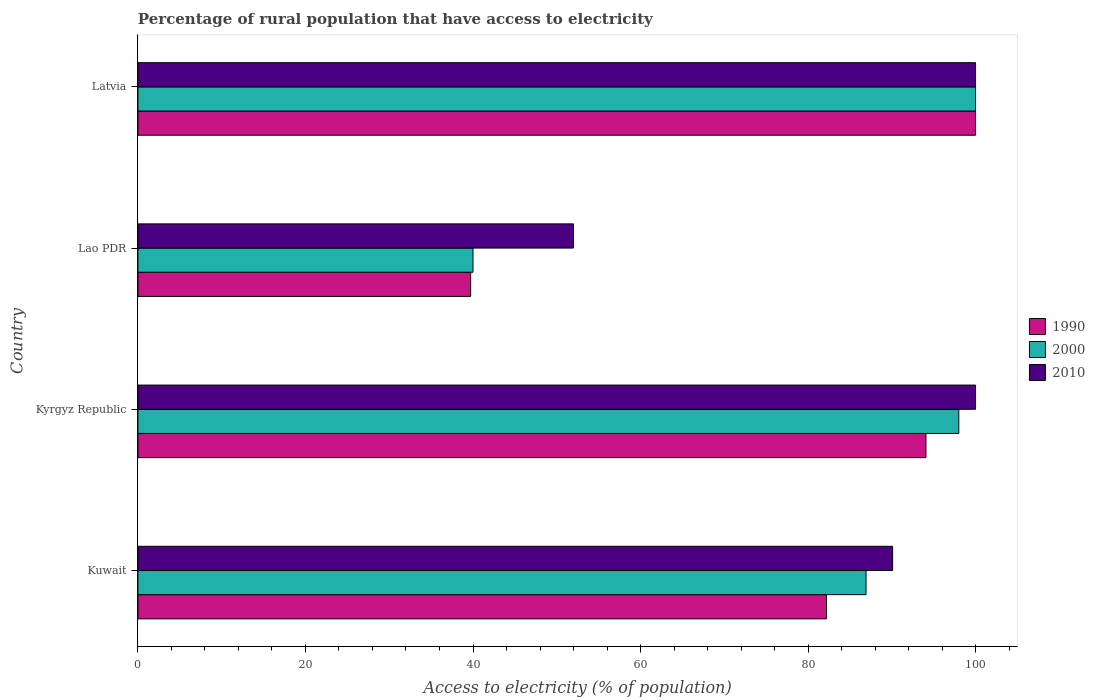Are the number of bars per tick equal to the number of legend labels?
Offer a very short reply. Yes. What is the label of the 4th group of bars from the top?
Keep it short and to the point. Kuwait. What is the percentage of rural population that have access to electricity in 2000 in Lao PDR?
Provide a succinct answer. 40. Across all countries, what is the maximum percentage of rural population that have access to electricity in 2010?
Your answer should be compact. 100. In which country was the percentage of rural population that have access to electricity in 1990 maximum?
Give a very brief answer. Latvia. In which country was the percentage of rural population that have access to electricity in 2000 minimum?
Provide a succinct answer. Lao PDR. What is the total percentage of rural population that have access to electricity in 2010 in the graph?
Your answer should be compact. 342.1. What is the difference between the percentage of rural population that have access to electricity in 1990 in Lao PDR and that in Latvia?
Your answer should be compact. -60.28. What is the difference between the percentage of rural population that have access to electricity in 2000 in Kuwait and the percentage of rural population that have access to electricity in 2010 in Latvia?
Provide a succinct answer. -13.07. What is the average percentage of rural population that have access to electricity in 2000 per country?
Ensure brevity in your answer.  81.23. What is the difference between the percentage of rural population that have access to electricity in 2000 and percentage of rural population that have access to electricity in 1990 in Kuwait?
Offer a very short reply. 4.72. What is the ratio of the percentage of rural population that have access to electricity in 2000 in Kuwait to that in Lao PDR?
Offer a very short reply. 2.17. What is the difference between the highest and the lowest percentage of rural population that have access to electricity in 1990?
Your response must be concise. 60.28. In how many countries, is the percentage of rural population that have access to electricity in 2010 greater than the average percentage of rural population that have access to electricity in 2010 taken over all countries?
Your answer should be very brief. 3. Is it the case that in every country, the sum of the percentage of rural population that have access to electricity in 2010 and percentage of rural population that have access to electricity in 2000 is greater than the percentage of rural population that have access to electricity in 1990?
Provide a succinct answer. Yes. What is the difference between two consecutive major ticks on the X-axis?
Provide a succinct answer. 20. Does the graph contain any zero values?
Make the answer very short. No. How many legend labels are there?
Ensure brevity in your answer.  3. What is the title of the graph?
Your answer should be compact. Percentage of rural population that have access to electricity. Does "1977" appear as one of the legend labels in the graph?
Provide a succinct answer. No. What is the label or title of the X-axis?
Keep it short and to the point. Access to electricity (% of population). What is the label or title of the Y-axis?
Make the answer very short. Country. What is the Access to electricity (% of population) in 1990 in Kuwait?
Your answer should be very brief. 82.2. What is the Access to electricity (% of population) of 2000 in Kuwait?
Offer a terse response. 86.93. What is the Access to electricity (% of population) in 2010 in Kuwait?
Offer a very short reply. 90.1. What is the Access to electricity (% of population) in 1990 in Kyrgyz Republic?
Make the answer very short. 94.08. What is the Access to electricity (% of population) of 1990 in Lao PDR?
Provide a succinct answer. 39.72. What is the Access to electricity (% of population) of 2000 in Lao PDR?
Provide a short and direct response. 40. What is the Access to electricity (% of population) in 2010 in Lao PDR?
Provide a succinct answer. 52. Across all countries, what is the maximum Access to electricity (% of population) of 1990?
Your answer should be compact. 100. Across all countries, what is the maximum Access to electricity (% of population) of 2000?
Keep it short and to the point. 100. Across all countries, what is the minimum Access to electricity (% of population) of 1990?
Keep it short and to the point. 39.72. Across all countries, what is the minimum Access to electricity (% of population) of 2000?
Keep it short and to the point. 40. What is the total Access to electricity (% of population) of 1990 in the graph?
Give a very brief answer. 316. What is the total Access to electricity (% of population) in 2000 in the graph?
Offer a terse response. 324.93. What is the total Access to electricity (% of population) of 2010 in the graph?
Ensure brevity in your answer.  342.1. What is the difference between the Access to electricity (% of population) in 1990 in Kuwait and that in Kyrgyz Republic?
Your response must be concise. -11.88. What is the difference between the Access to electricity (% of population) of 2000 in Kuwait and that in Kyrgyz Republic?
Your answer should be compact. -11.07. What is the difference between the Access to electricity (% of population) in 1990 in Kuwait and that in Lao PDR?
Offer a terse response. 42.48. What is the difference between the Access to electricity (% of population) in 2000 in Kuwait and that in Lao PDR?
Ensure brevity in your answer.  46.93. What is the difference between the Access to electricity (% of population) of 2010 in Kuwait and that in Lao PDR?
Offer a terse response. 38.1. What is the difference between the Access to electricity (% of population) in 1990 in Kuwait and that in Latvia?
Give a very brief answer. -17.8. What is the difference between the Access to electricity (% of population) in 2000 in Kuwait and that in Latvia?
Your answer should be very brief. -13.07. What is the difference between the Access to electricity (% of population) of 2010 in Kuwait and that in Latvia?
Make the answer very short. -9.9. What is the difference between the Access to electricity (% of population) of 1990 in Kyrgyz Republic and that in Lao PDR?
Keep it short and to the point. 54.36. What is the difference between the Access to electricity (% of population) in 2000 in Kyrgyz Republic and that in Lao PDR?
Keep it short and to the point. 58. What is the difference between the Access to electricity (% of population) of 1990 in Kyrgyz Republic and that in Latvia?
Your response must be concise. -5.92. What is the difference between the Access to electricity (% of population) in 2000 in Kyrgyz Republic and that in Latvia?
Ensure brevity in your answer.  -2. What is the difference between the Access to electricity (% of population) in 2010 in Kyrgyz Republic and that in Latvia?
Ensure brevity in your answer.  0. What is the difference between the Access to electricity (% of population) in 1990 in Lao PDR and that in Latvia?
Your answer should be very brief. -60.28. What is the difference between the Access to electricity (% of population) in 2000 in Lao PDR and that in Latvia?
Make the answer very short. -60. What is the difference between the Access to electricity (% of population) of 2010 in Lao PDR and that in Latvia?
Ensure brevity in your answer.  -48. What is the difference between the Access to electricity (% of population) in 1990 in Kuwait and the Access to electricity (% of population) in 2000 in Kyrgyz Republic?
Offer a terse response. -15.8. What is the difference between the Access to electricity (% of population) of 1990 in Kuwait and the Access to electricity (% of population) of 2010 in Kyrgyz Republic?
Keep it short and to the point. -17.8. What is the difference between the Access to electricity (% of population) of 2000 in Kuwait and the Access to electricity (% of population) of 2010 in Kyrgyz Republic?
Provide a short and direct response. -13.07. What is the difference between the Access to electricity (% of population) in 1990 in Kuwait and the Access to electricity (% of population) in 2000 in Lao PDR?
Provide a short and direct response. 42.2. What is the difference between the Access to electricity (% of population) of 1990 in Kuwait and the Access to electricity (% of population) of 2010 in Lao PDR?
Ensure brevity in your answer.  30.2. What is the difference between the Access to electricity (% of population) in 2000 in Kuwait and the Access to electricity (% of population) in 2010 in Lao PDR?
Provide a succinct answer. 34.93. What is the difference between the Access to electricity (% of population) of 1990 in Kuwait and the Access to electricity (% of population) of 2000 in Latvia?
Offer a very short reply. -17.8. What is the difference between the Access to electricity (% of population) of 1990 in Kuwait and the Access to electricity (% of population) of 2010 in Latvia?
Ensure brevity in your answer.  -17.8. What is the difference between the Access to electricity (% of population) in 2000 in Kuwait and the Access to electricity (% of population) in 2010 in Latvia?
Keep it short and to the point. -13.07. What is the difference between the Access to electricity (% of population) in 1990 in Kyrgyz Republic and the Access to electricity (% of population) in 2000 in Lao PDR?
Your response must be concise. 54.08. What is the difference between the Access to electricity (% of population) of 1990 in Kyrgyz Republic and the Access to electricity (% of population) of 2010 in Lao PDR?
Your response must be concise. 42.08. What is the difference between the Access to electricity (% of population) in 2000 in Kyrgyz Republic and the Access to electricity (% of population) in 2010 in Lao PDR?
Provide a succinct answer. 46. What is the difference between the Access to electricity (% of population) of 1990 in Kyrgyz Republic and the Access to electricity (% of population) of 2000 in Latvia?
Provide a succinct answer. -5.92. What is the difference between the Access to electricity (% of population) of 1990 in Kyrgyz Republic and the Access to electricity (% of population) of 2010 in Latvia?
Offer a terse response. -5.92. What is the difference between the Access to electricity (% of population) of 1990 in Lao PDR and the Access to electricity (% of population) of 2000 in Latvia?
Make the answer very short. -60.28. What is the difference between the Access to electricity (% of population) in 1990 in Lao PDR and the Access to electricity (% of population) in 2010 in Latvia?
Offer a very short reply. -60.28. What is the difference between the Access to electricity (% of population) of 2000 in Lao PDR and the Access to electricity (% of population) of 2010 in Latvia?
Your response must be concise. -60. What is the average Access to electricity (% of population) of 1990 per country?
Give a very brief answer. 79. What is the average Access to electricity (% of population) of 2000 per country?
Provide a succinct answer. 81.23. What is the average Access to electricity (% of population) of 2010 per country?
Provide a succinct answer. 85.53. What is the difference between the Access to electricity (% of population) in 1990 and Access to electricity (% of population) in 2000 in Kuwait?
Ensure brevity in your answer.  -4.72. What is the difference between the Access to electricity (% of population) of 1990 and Access to electricity (% of population) of 2010 in Kuwait?
Offer a very short reply. -7.9. What is the difference between the Access to electricity (% of population) of 2000 and Access to electricity (% of population) of 2010 in Kuwait?
Provide a succinct answer. -3.17. What is the difference between the Access to electricity (% of population) of 1990 and Access to electricity (% of population) of 2000 in Kyrgyz Republic?
Provide a succinct answer. -3.92. What is the difference between the Access to electricity (% of population) of 1990 and Access to electricity (% of population) of 2010 in Kyrgyz Republic?
Give a very brief answer. -5.92. What is the difference between the Access to electricity (% of population) in 1990 and Access to electricity (% of population) in 2000 in Lao PDR?
Make the answer very short. -0.28. What is the difference between the Access to electricity (% of population) in 1990 and Access to electricity (% of population) in 2010 in Lao PDR?
Your answer should be compact. -12.28. What is the difference between the Access to electricity (% of population) of 2000 and Access to electricity (% of population) of 2010 in Latvia?
Provide a succinct answer. 0. What is the ratio of the Access to electricity (% of population) in 1990 in Kuwait to that in Kyrgyz Republic?
Your answer should be compact. 0.87. What is the ratio of the Access to electricity (% of population) in 2000 in Kuwait to that in Kyrgyz Republic?
Make the answer very short. 0.89. What is the ratio of the Access to electricity (% of population) of 2010 in Kuwait to that in Kyrgyz Republic?
Make the answer very short. 0.9. What is the ratio of the Access to electricity (% of population) of 1990 in Kuwait to that in Lao PDR?
Your response must be concise. 2.07. What is the ratio of the Access to electricity (% of population) in 2000 in Kuwait to that in Lao PDR?
Ensure brevity in your answer.  2.17. What is the ratio of the Access to electricity (% of population) in 2010 in Kuwait to that in Lao PDR?
Give a very brief answer. 1.73. What is the ratio of the Access to electricity (% of population) in 1990 in Kuwait to that in Latvia?
Keep it short and to the point. 0.82. What is the ratio of the Access to electricity (% of population) of 2000 in Kuwait to that in Latvia?
Make the answer very short. 0.87. What is the ratio of the Access to electricity (% of population) in 2010 in Kuwait to that in Latvia?
Ensure brevity in your answer.  0.9. What is the ratio of the Access to electricity (% of population) in 1990 in Kyrgyz Republic to that in Lao PDR?
Provide a short and direct response. 2.37. What is the ratio of the Access to electricity (% of population) in 2000 in Kyrgyz Republic to that in Lao PDR?
Make the answer very short. 2.45. What is the ratio of the Access to electricity (% of population) of 2010 in Kyrgyz Republic to that in Lao PDR?
Keep it short and to the point. 1.92. What is the ratio of the Access to electricity (% of population) in 1990 in Kyrgyz Republic to that in Latvia?
Ensure brevity in your answer.  0.94. What is the ratio of the Access to electricity (% of population) of 2000 in Kyrgyz Republic to that in Latvia?
Provide a succinct answer. 0.98. What is the ratio of the Access to electricity (% of population) of 2010 in Kyrgyz Republic to that in Latvia?
Offer a terse response. 1. What is the ratio of the Access to electricity (% of population) in 1990 in Lao PDR to that in Latvia?
Your answer should be compact. 0.4. What is the ratio of the Access to electricity (% of population) of 2000 in Lao PDR to that in Latvia?
Offer a very short reply. 0.4. What is the ratio of the Access to electricity (% of population) of 2010 in Lao PDR to that in Latvia?
Your answer should be very brief. 0.52. What is the difference between the highest and the second highest Access to electricity (% of population) in 1990?
Your answer should be compact. 5.92. What is the difference between the highest and the second highest Access to electricity (% of population) of 2000?
Make the answer very short. 2. What is the difference between the highest and the lowest Access to electricity (% of population) of 1990?
Offer a terse response. 60.28. What is the difference between the highest and the lowest Access to electricity (% of population) of 2000?
Ensure brevity in your answer.  60. 